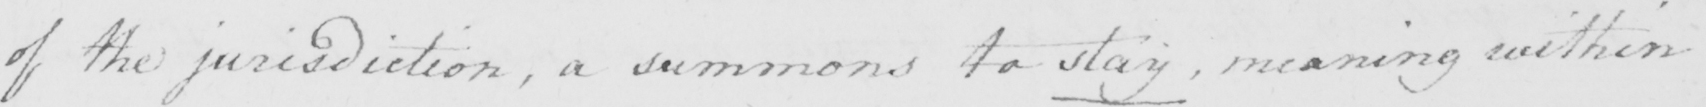Can you tell me what this handwritten text says? of the jurisdiction  , a summons to stay , meaning within 